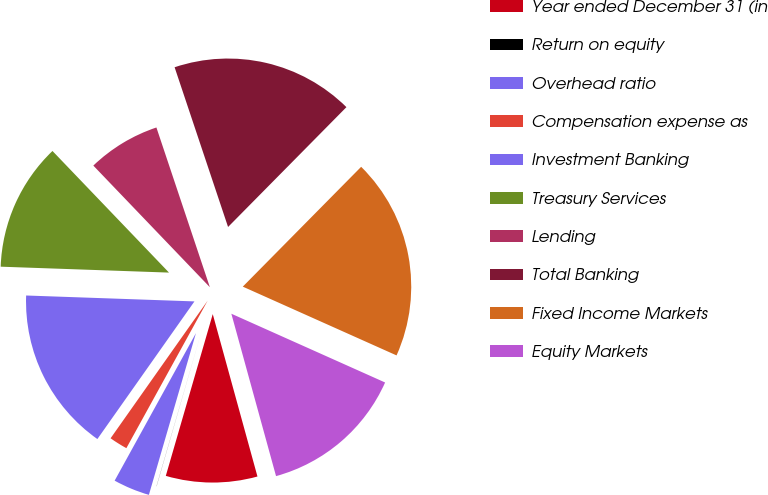Convert chart to OTSL. <chart><loc_0><loc_0><loc_500><loc_500><pie_chart><fcel>Year ended December 31 (in<fcel>Return on equity<fcel>Overhead ratio<fcel>Compensation expense as<fcel>Investment Banking<fcel>Treasury Services<fcel>Lending<fcel>Total Banking<fcel>Fixed Income Markets<fcel>Equity Markets<nl><fcel>8.77%<fcel>0.01%<fcel>3.51%<fcel>1.76%<fcel>15.78%<fcel>12.28%<fcel>7.02%<fcel>17.54%<fcel>19.29%<fcel>14.03%<nl></chart> 